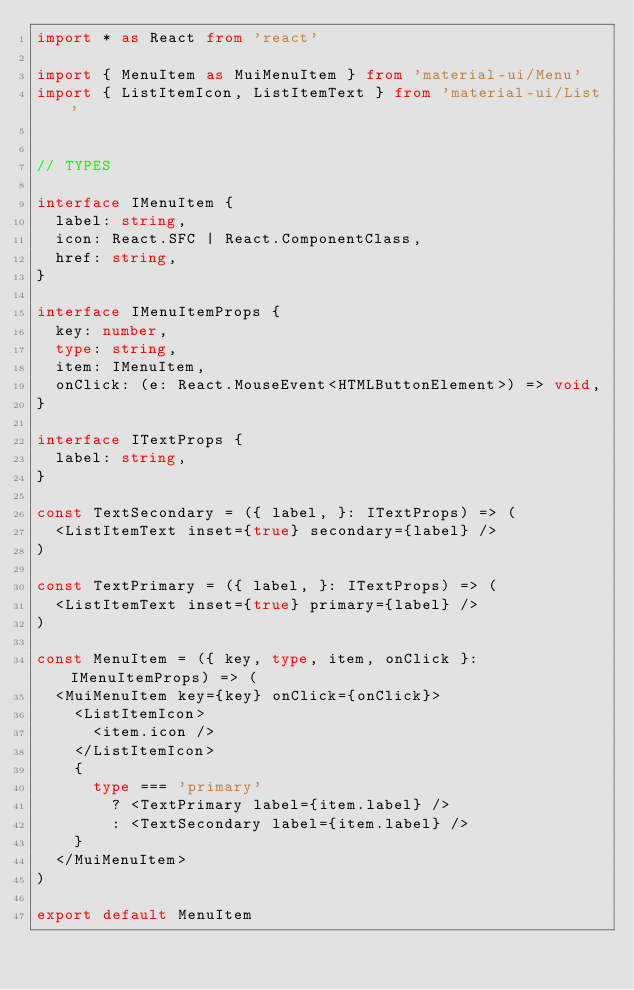<code> <loc_0><loc_0><loc_500><loc_500><_TypeScript_>import * as React from 'react'

import { MenuItem as MuiMenuItem } from 'material-ui/Menu'
import { ListItemIcon, ListItemText } from 'material-ui/List'


// TYPES 

interface IMenuItem {
  label: string,
  icon: React.SFC | React.ComponentClass,
  href: string,
}

interface IMenuItemProps {
  key: number,
  type: string,
  item: IMenuItem,
  onClick: (e: React.MouseEvent<HTMLButtonElement>) => void,
}

interface ITextProps {
  label: string,
}

const TextSecondary = ({ label, }: ITextProps) => (
  <ListItemText inset={true} secondary={label} />
)

const TextPrimary = ({ label, }: ITextProps) => (
  <ListItemText inset={true} primary={label} />
)

const MenuItem = ({ key, type, item, onClick }: IMenuItemProps) => (
  <MuiMenuItem key={key} onClick={onClick}>
    <ListItemIcon>
      <item.icon />
    </ListItemIcon>
    {
      type === 'primary'
        ? <TextPrimary label={item.label} />
        : <TextSecondary label={item.label} />
    }
  </MuiMenuItem>
)

export default MenuItem
</code> 